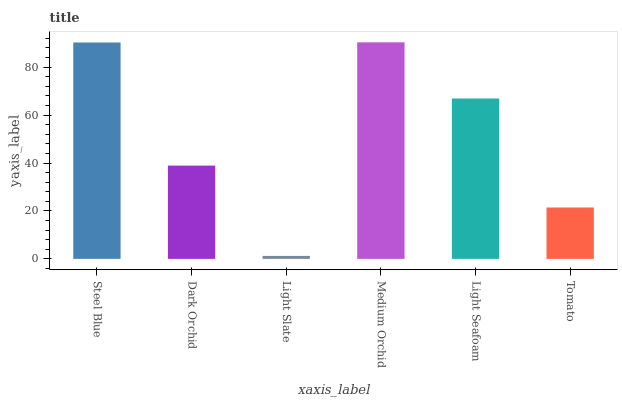Is Light Slate the minimum?
Answer yes or no. Yes. Is Medium Orchid the maximum?
Answer yes or no. Yes. Is Dark Orchid the minimum?
Answer yes or no. No. Is Dark Orchid the maximum?
Answer yes or no. No. Is Steel Blue greater than Dark Orchid?
Answer yes or no. Yes. Is Dark Orchid less than Steel Blue?
Answer yes or no. Yes. Is Dark Orchid greater than Steel Blue?
Answer yes or no. No. Is Steel Blue less than Dark Orchid?
Answer yes or no. No. Is Light Seafoam the high median?
Answer yes or no. Yes. Is Dark Orchid the low median?
Answer yes or no. Yes. Is Medium Orchid the high median?
Answer yes or no. No. Is Light Seafoam the low median?
Answer yes or no. No. 